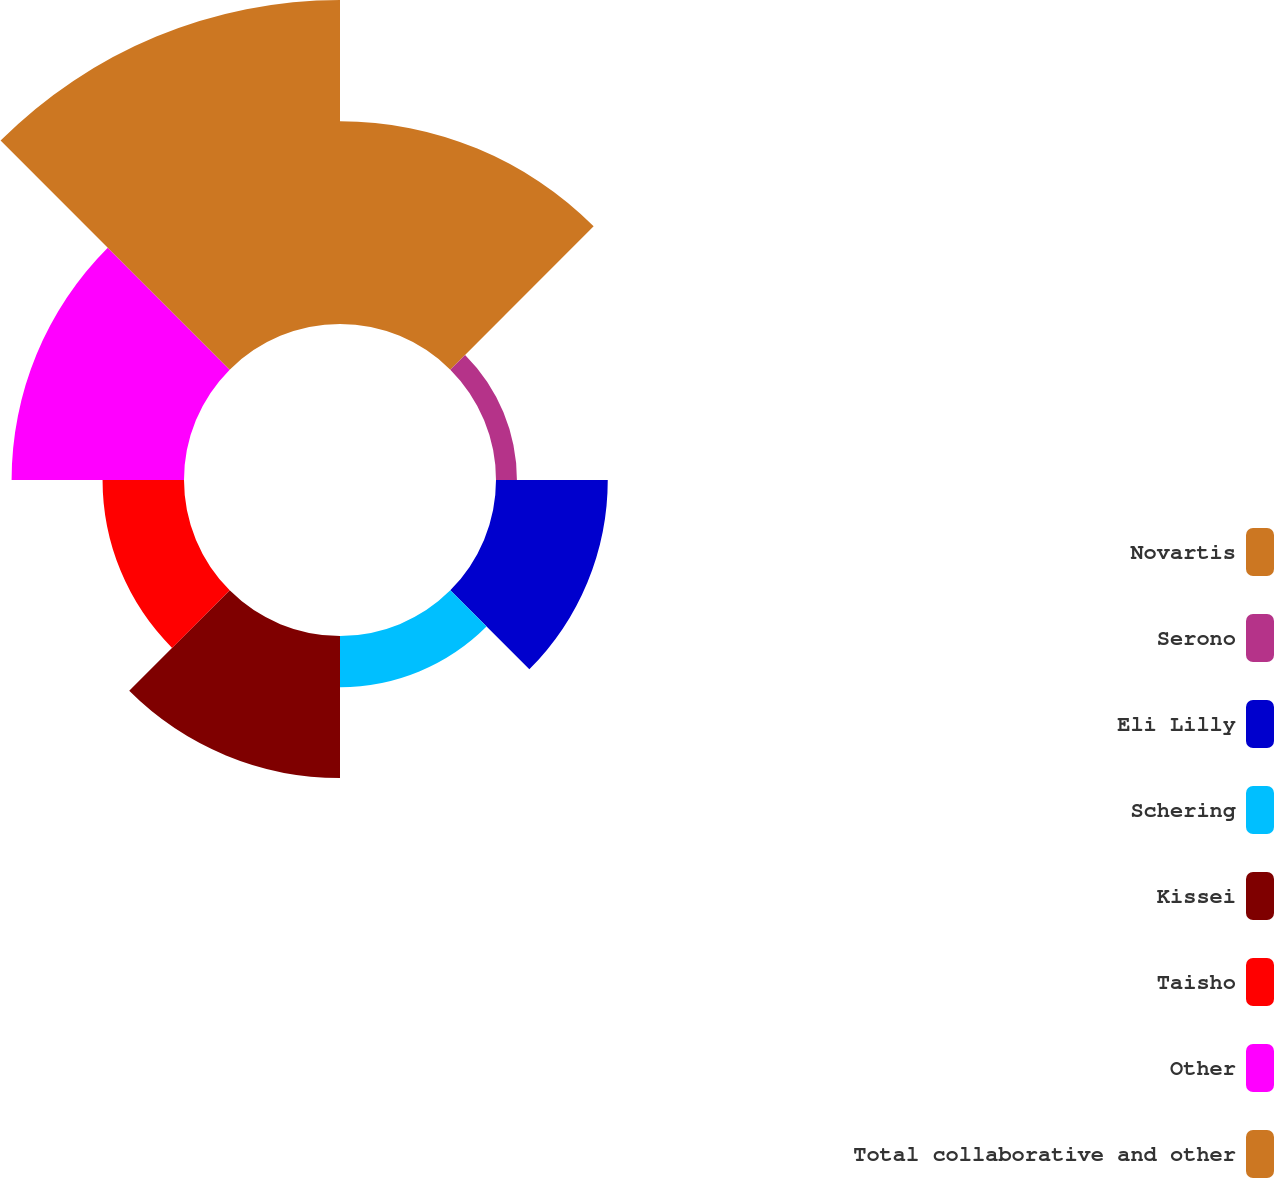Convert chart to OTSL. <chart><loc_0><loc_0><loc_500><loc_500><pie_chart><fcel>Novartis<fcel>Serono<fcel>Eli Lilly<fcel>Schering<fcel>Kissei<fcel>Taisho<fcel>Other<fcel>Total collaborative and other<nl><fcel>18.32%<fcel>1.89%<fcel>10.1%<fcel>4.63%<fcel>12.84%<fcel>7.36%<fcel>15.58%<fcel>29.28%<nl></chart> 